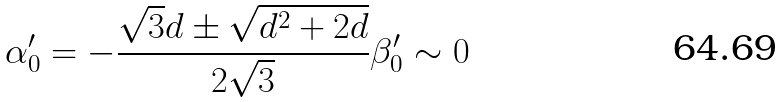Convert formula to latex. <formula><loc_0><loc_0><loc_500><loc_500>\alpha _ { 0 } ^ { \prime } = - { \frac { \sqrt { 3 } d \pm \sqrt { d ^ { 2 } + 2 d } } { 2 \sqrt { 3 } } } \beta _ { 0 } ^ { \prime } \sim 0</formula> 